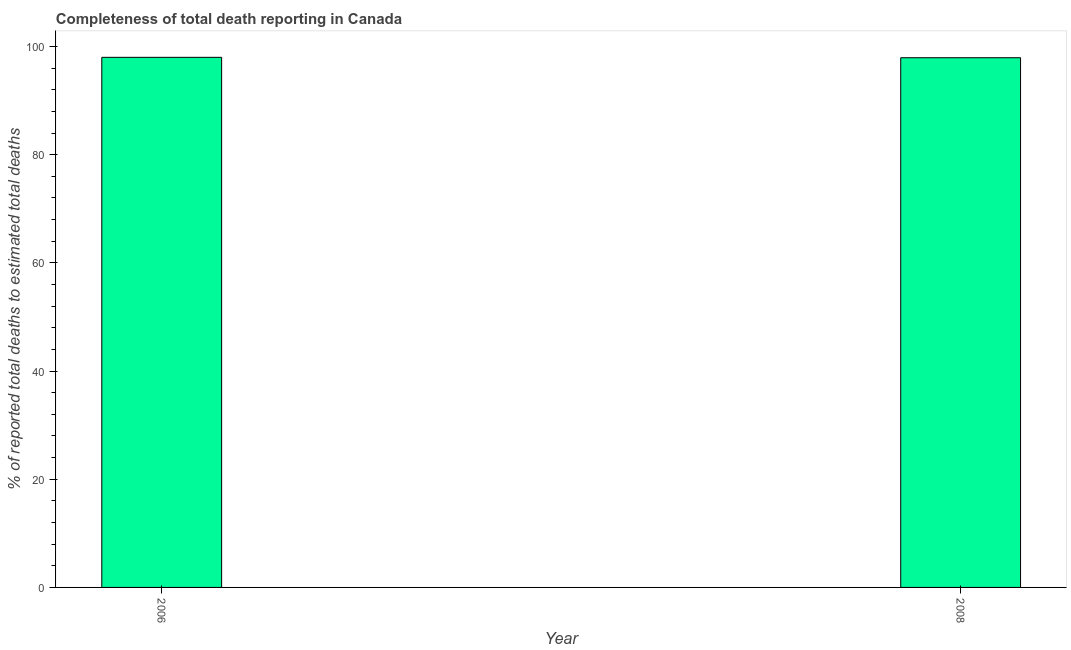Does the graph contain grids?
Keep it short and to the point. No. What is the title of the graph?
Keep it short and to the point. Completeness of total death reporting in Canada. What is the label or title of the X-axis?
Your response must be concise. Year. What is the label or title of the Y-axis?
Your response must be concise. % of reported total deaths to estimated total deaths. What is the completeness of total death reports in 2008?
Give a very brief answer. 97.92. Across all years, what is the maximum completeness of total death reports?
Make the answer very short. 97.99. Across all years, what is the minimum completeness of total death reports?
Your answer should be very brief. 97.92. In which year was the completeness of total death reports maximum?
Offer a terse response. 2006. In which year was the completeness of total death reports minimum?
Your answer should be compact. 2008. What is the sum of the completeness of total death reports?
Give a very brief answer. 195.91. What is the difference between the completeness of total death reports in 2006 and 2008?
Make the answer very short. 0.07. What is the average completeness of total death reports per year?
Make the answer very short. 97.95. What is the median completeness of total death reports?
Give a very brief answer. 97.95. In how many years, is the completeness of total death reports greater than 72 %?
Keep it short and to the point. 2. Do a majority of the years between 2008 and 2006 (inclusive) have completeness of total death reports greater than 40 %?
Keep it short and to the point. No. What is the ratio of the completeness of total death reports in 2006 to that in 2008?
Make the answer very short. 1. Is the completeness of total death reports in 2006 less than that in 2008?
Your response must be concise. No. How many bars are there?
Your answer should be compact. 2. What is the difference between two consecutive major ticks on the Y-axis?
Give a very brief answer. 20. Are the values on the major ticks of Y-axis written in scientific E-notation?
Provide a short and direct response. No. What is the % of reported total deaths to estimated total deaths in 2006?
Ensure brevity in your answer.  97.99. What is the % of reported total deaths to estimated total deaths of 2008?
Ensure brevity in your answer.  97.92. What is the difference between the % of reported total deaths to estimated total deaths in 2006 and 2008?
Offer a terse response. 0.07. 